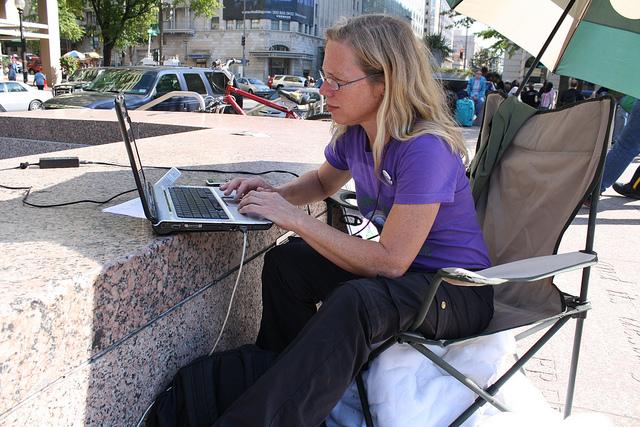Who is using the laptop?
Short answer required. Woman. Where are the cars parked?
Short answer required. Street. Is the woman having glasses?
Answer briefly. Yes. What color is the tablecloth?
Keep it brief. White. Who is the woman emailing?
Write a very short answer. Friend. Is it highly unlikely this woman had two blonde parents?
Keep it brief. No. 